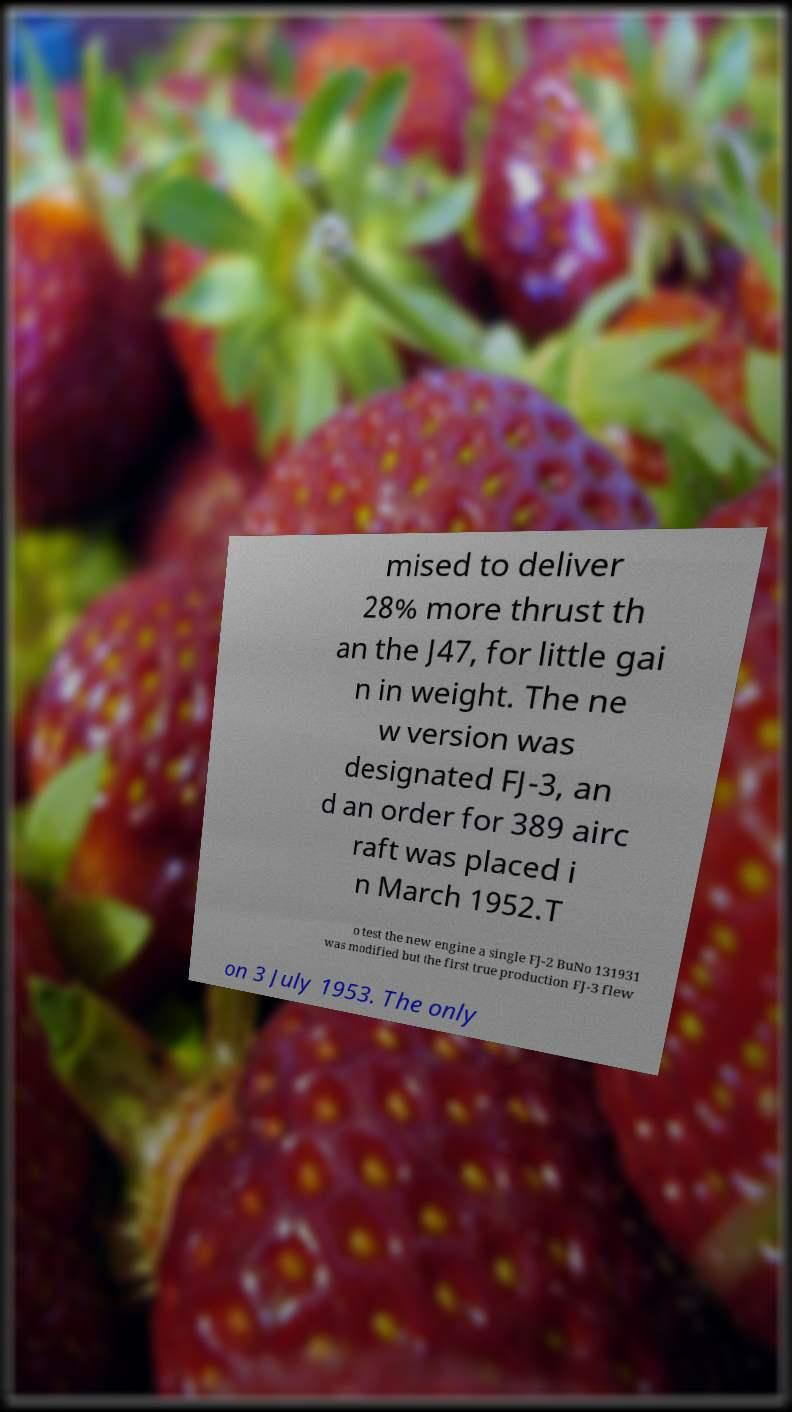Could you extract and type out the text from this image? mised to deliver 28% more thrust th an the J47, for little gai n in weight. The ne w version was designated FJ-3, an d an order for 389 airc raft was placed i n March 1952.T o test the new engine a single FJ-2 BuNo 131931 was modified but the first true production FJ-3 flew on 3 July 1953. The only 